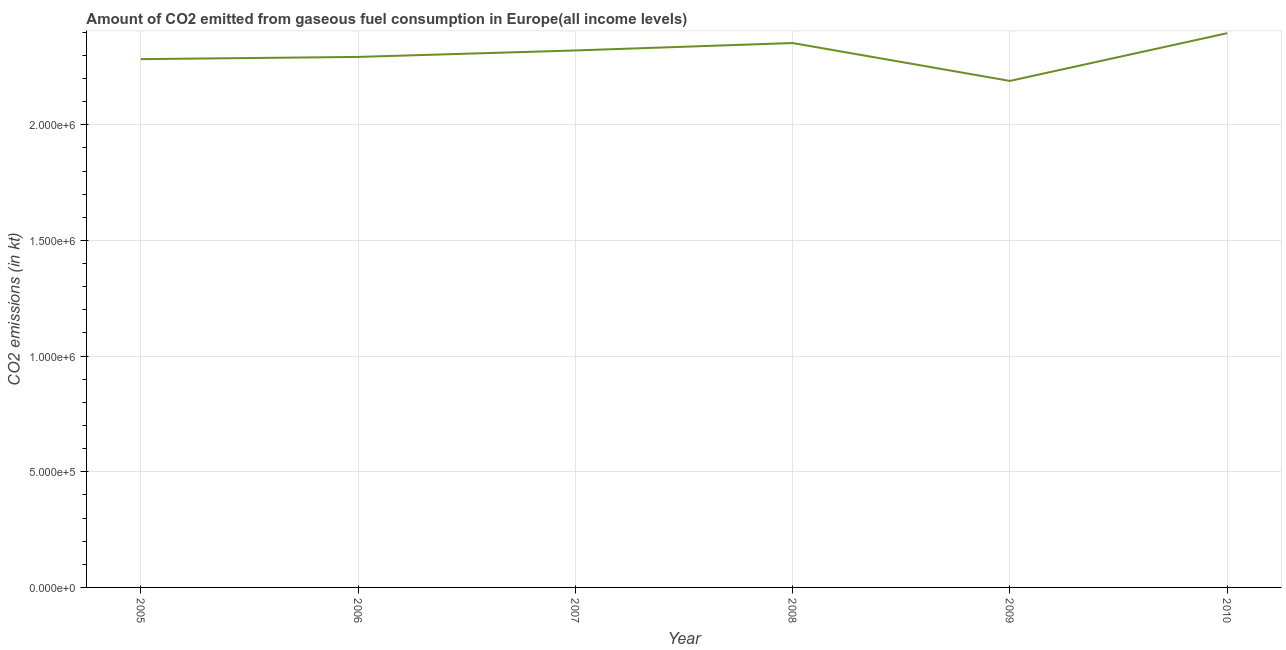What is the co2 emissions from gaseous fuel consumption in 2008?
Make the answer very short. 2.35e+06. Across all years, what is the maximum co2 emissions from gaseous fuel consumption?
Your response must be concise. 2.40e+06. Across all years, what is the minimum co2 emissions from gaseous fuel consumption?
Provide a succinct answer. 2.19e+06. In which year was the co2 emissions from gaseous fuel consumption maximum?
Provide a succinct answer. 2010. What is the sum of the co2 emissions from gaseous fuel consumption?
Your answer should be very brief. 1.38e+07. What is the difference between the co2 emissions from gaseous fuel consumption in 2007 and 2010?
Give a very brief answer. -7.46e+04. What is the average co2 emissions from gaseous fuel consumption per year?
Your response must be concise. 2.31e+06. What is the median co2 emissions from gaseous fuel consumption?
Your answer should be very brief. 2.31e+06. In how many years, is the co2 emissions from gaseous fuel consumption greater than 1100000 kt?
Make the answer very short. 6. Do a majority of the years between 2009 and 2010 (inclusive) have co2 emissions from gaseous fuel consumption greater than 1300000 kt?
Give a very brief answer. Yes. What is the ratio of the co2 emissions from gaseous fuel consumption in 2008 to that in 2009?
Offer a terse response. 1.07. What is the difference between the highest and the second highest co2 emissions from gaseous fuel consumption?
Offer a very short reply. 4.25e+04. Is the sum of the co2 emissions from gaseous fuel consumption in 2005 and 2008 greater than the maximum co2 emissions from gaseous fuel consumption across all years?
Your response must be concise. Yes. What is the difference between the highest and the lowest co2 emissions from gaseous fuel consumption?
Provide a short and direct response. 2.06e+05. In how many years, is the co2 emissions from gaseous fuel consumption greater than the average co2 emissions from gaseous fuel consumption taken over all years?
Your response must be concise. 3. Does the co2 emissions from gaseous fuel consumption monotonically increase over the years?
Your response must be concise. No. How many lines are there?
Your response must be concise. 1. How many years are there in the graph?
Provide a succinct answer. 6. What is the difference between two consecutive major ticks on the Y-axis?
Your response must be concise. 5.00e+05. Are the values on the major ticks of Y-axis written in scientific E-notation?
Provide a short and direct response. Yes. What is the title of the graph?
Provide a succinct answer. Amount of CO2 emitted from gaseous fuel consumption in Europe(all income levels). What is the label or title of the Y-axis?
Your answer should be compact. CO2 emissions (in kt). What is the CO2 emissions (in kt) in 2005?
Your answer should be compact. 2.28e+06. What is the CO2 emissions (in kt) in 2006?
Your answer should be compact. 2.29e+06. What is the CO2 emissions (in kt) of 2007?
Offer a terse response. 2.32e+06. What is the CO2 emissions (in kt) of 2008?
Make the answer very short. 2.35e+06. What is the CO2 emissions (in kt) of 2009?
Offer a terse response. 2.19e+06. What is the CO2 emissions (in kt) in 2010?
Your answer should be very brief. 2.40e+06. What is the difference between the CO2 emissions (in kt) in 2005 and 2006?
Give a very brief answer. -9615.06. What is the difference between the CO2 emissions (in kt) in 2005 and 2007?
Make the answer very short. -3.75e+04. What is the difference between the CO2 emissions (in kt) in 2005 and 2008?
Make the answer very short. -6.96e+04. What is the difference between the CO2 emissions (in kt) in 2005 and 2009?
Your answer should be very brief. 9.41e+04. What is the difference between the CO2 emissions (in kt) in 2005 and 2010?
Offer a very short reply. -1.12e+05. What is the difference between the CO2 emissions (in kt) in 2006 and 2007?
Your answer should be very brief. -2.79e+04. What is the difference between the CO2 emissions (in kt) in 2006 and 2008?
Your response must be concise. -6.00e+04. What is the difference between the CO2 emissions (in kt) in 2006 and 2009?
Provide a succinct answer. 1.04e+05. What is the difference between the CO2 emissions (in kt) in 2006 and 2010?
Your answer should be very brief. -1.02e+05. What is the difference between the CO2 emissions (in kt) in 2007 and 2008?
Offer a very short reply. -3.21e+04. What is the difference between the CO2 emissions (in kt) in 2007 and 2009?
Your response must be concise. 1.32e+05. What is the difference between the CO2 emissions (in kt) in 2007 and 2010?
Offer a terse response. -7.46e+04. What is the difference between the CO2 emissions (in kt) in 2008 and 2009?
Make the answer very short. 1.64e+05. What is the difference between the CO2 emissions (in kt) in 2008 and 2010?
Give a very brief answer. -4.25e+04. What is the difference between the CO2 emissions (in kt) in 2009 and 2010?
Provide a succinct answer. -2.06e+05. What is the ratio of the CO2 emissions (in kt) in 2005 to that in 2007?
Your answer should be very brief. 0.98. What is the ratio of the CO2 emissions (in kt) in 2005 to that in 2008?
Provide a succinct answer. 0.97. What is the ratio of the CO2 emissions (in kt) in 2005 to that in 2009?
Your answer should be very brief. 1.04. What is the ratio of the CO2 emissions (in kt) in 2005 to that in 2010?
Your answer should be compact. 0.95. What is the ratio of the CO2 emissions (in kt) in 2006 to that in 2007?
Give a very brief answer. 0.99. What is the ratio of the CO2 emissions (in kt) in 2006 to that in 2009?
Provide a succinct answer. 1.05. What is the ratio of the CO2 emissions (in kt) in 2007 to that in 2008?
Provide a short and direct response. 0.99. What is the ratio of the CO2 emissions (in kt) in 2007 to that in 2009?
Your answer should be very brief. 1.06. What is the ratio of the CO2 emissions (in kt) in 2007 to that in 2010?
Offer a terse response. 0.97. What is the ratio of the CO2 emissions (in kt) in 2008 to that in 2009?
Your response must be concise. 1.07. What is the ratio of the CO2 emissions (in kt) in 2008 to that in 2010?
Keep it short and to the point. 0.98. What is the ratio of the CO2 emissions (in kt) in 2009 to that in 2010?
Provide a short and direct response. 0.91. 